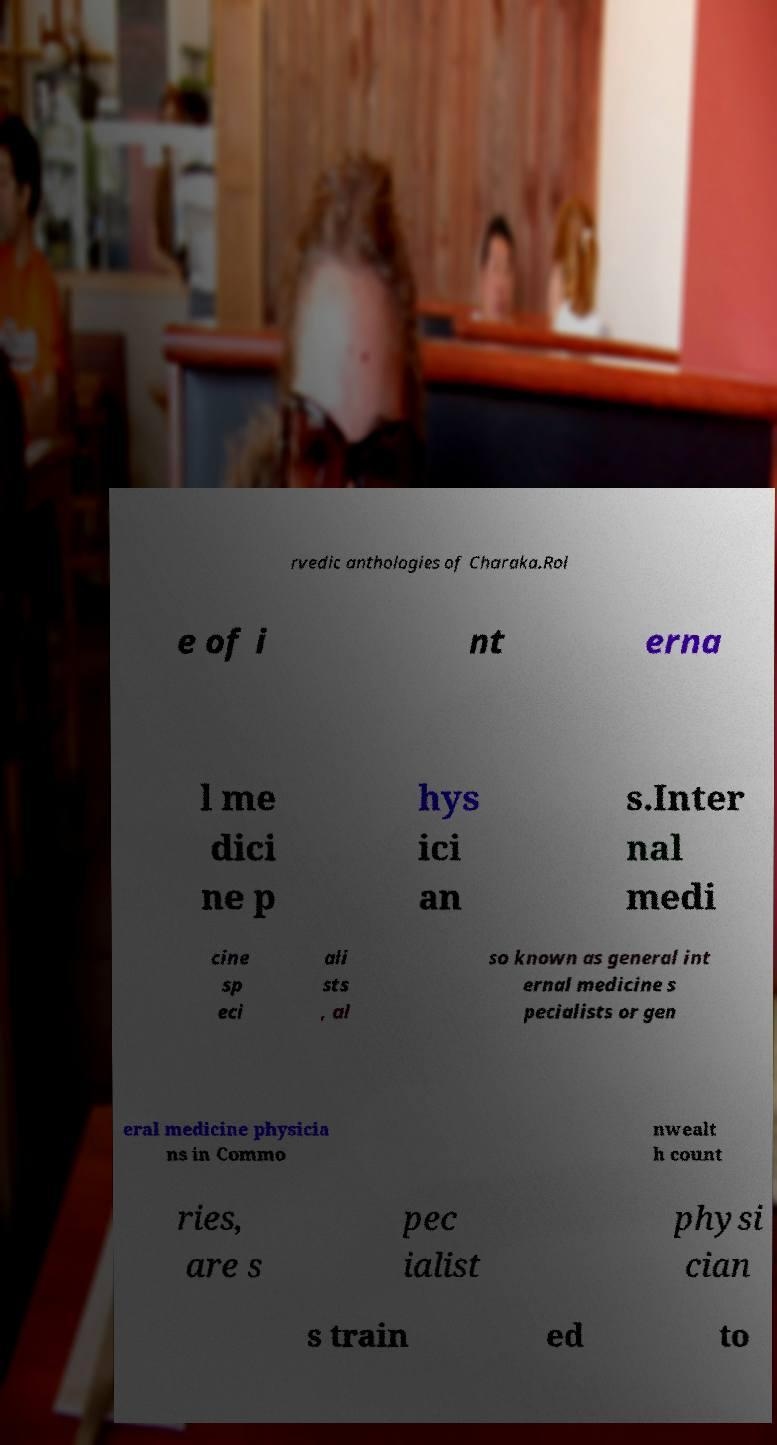Could you extract and type out the text from this image? rvedic anthologies of Charaka.Rol e of i nt erna l me dici ne p hys ici an s.Inter nal medi cine sp eci ali sts , al so known as general int ernal medicine s pecialists or gen eral medicine physicia ns in Commo nwealt h count ries, are s pec ialist physi cian s train ed to 